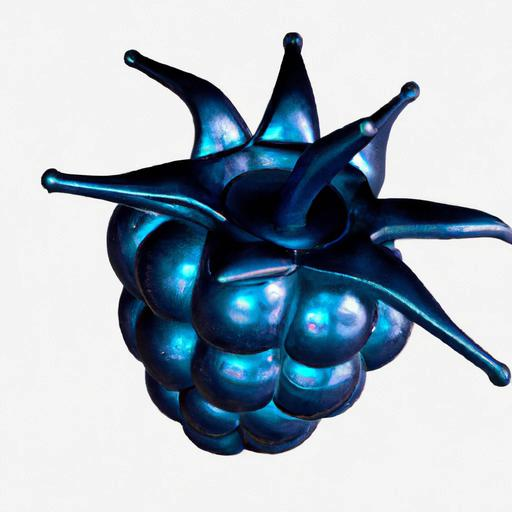What material might this object be made of? The object's iridescent finish gives it a metallic look, but it's likely a digital rendering designed to resemble a shiny, metallic surface. 